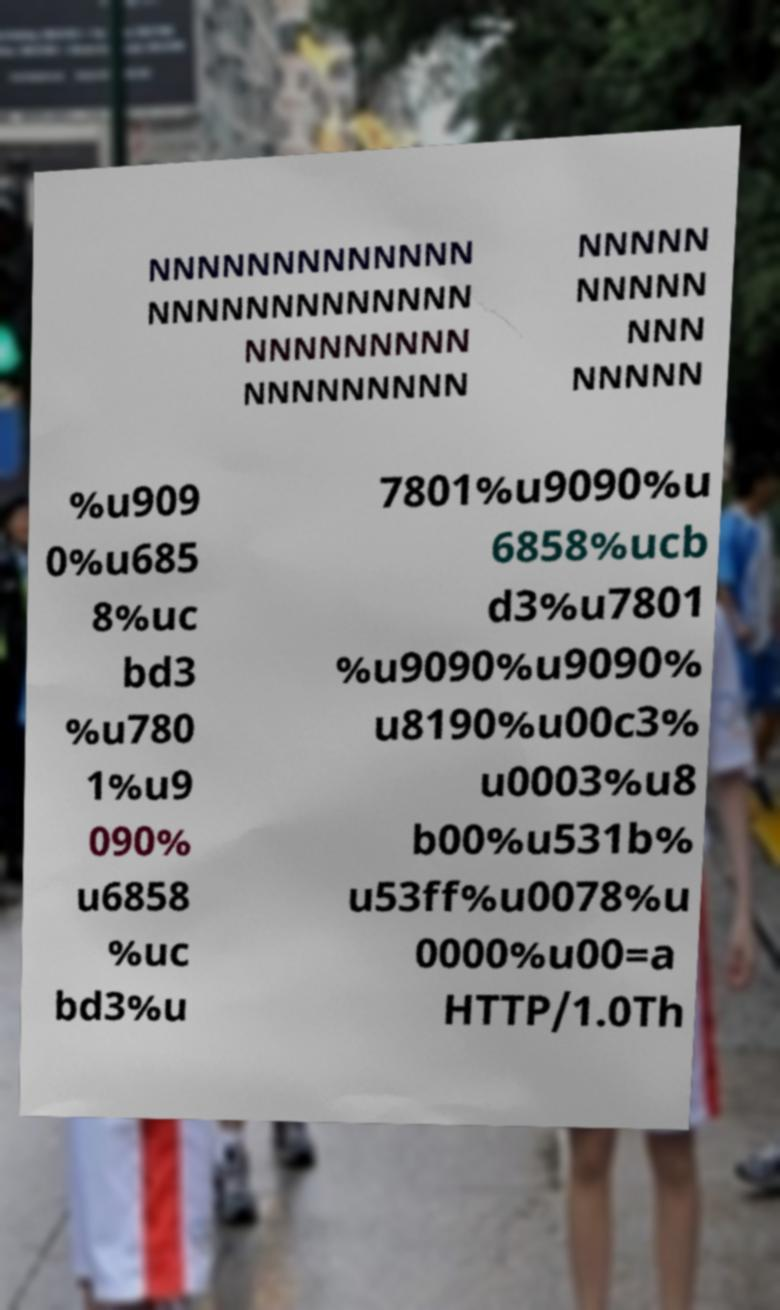Could you extract and type out the text from this image? NNNNNNNNNNNNN NNNNNNNNNNNNN NNNNNNNNN NNNNNNNNN NNNNN NNNNN NNN NNNNN %u909 0%u685 8%uc bd3 %u780 1%u9 090% u6858 %uc bd3%u 7801%u9090%u 6858%ucb d3%u7801 %u9090%u9090% u8190%u00c3% u0003%u8 b00%u531b% u53ff%u0078%u 0000%u00=a HTTP/1.0Th 